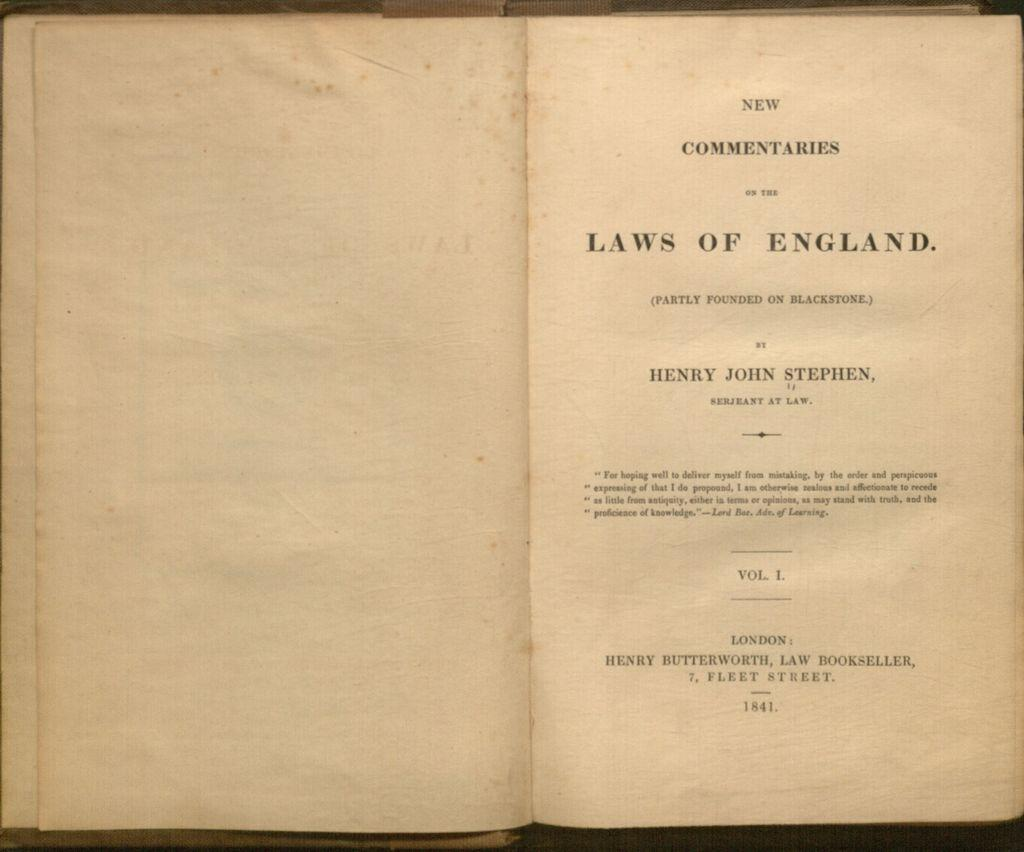<image>
Provide a brief description of the given image. A page of a book that had the title "Laws of England". 